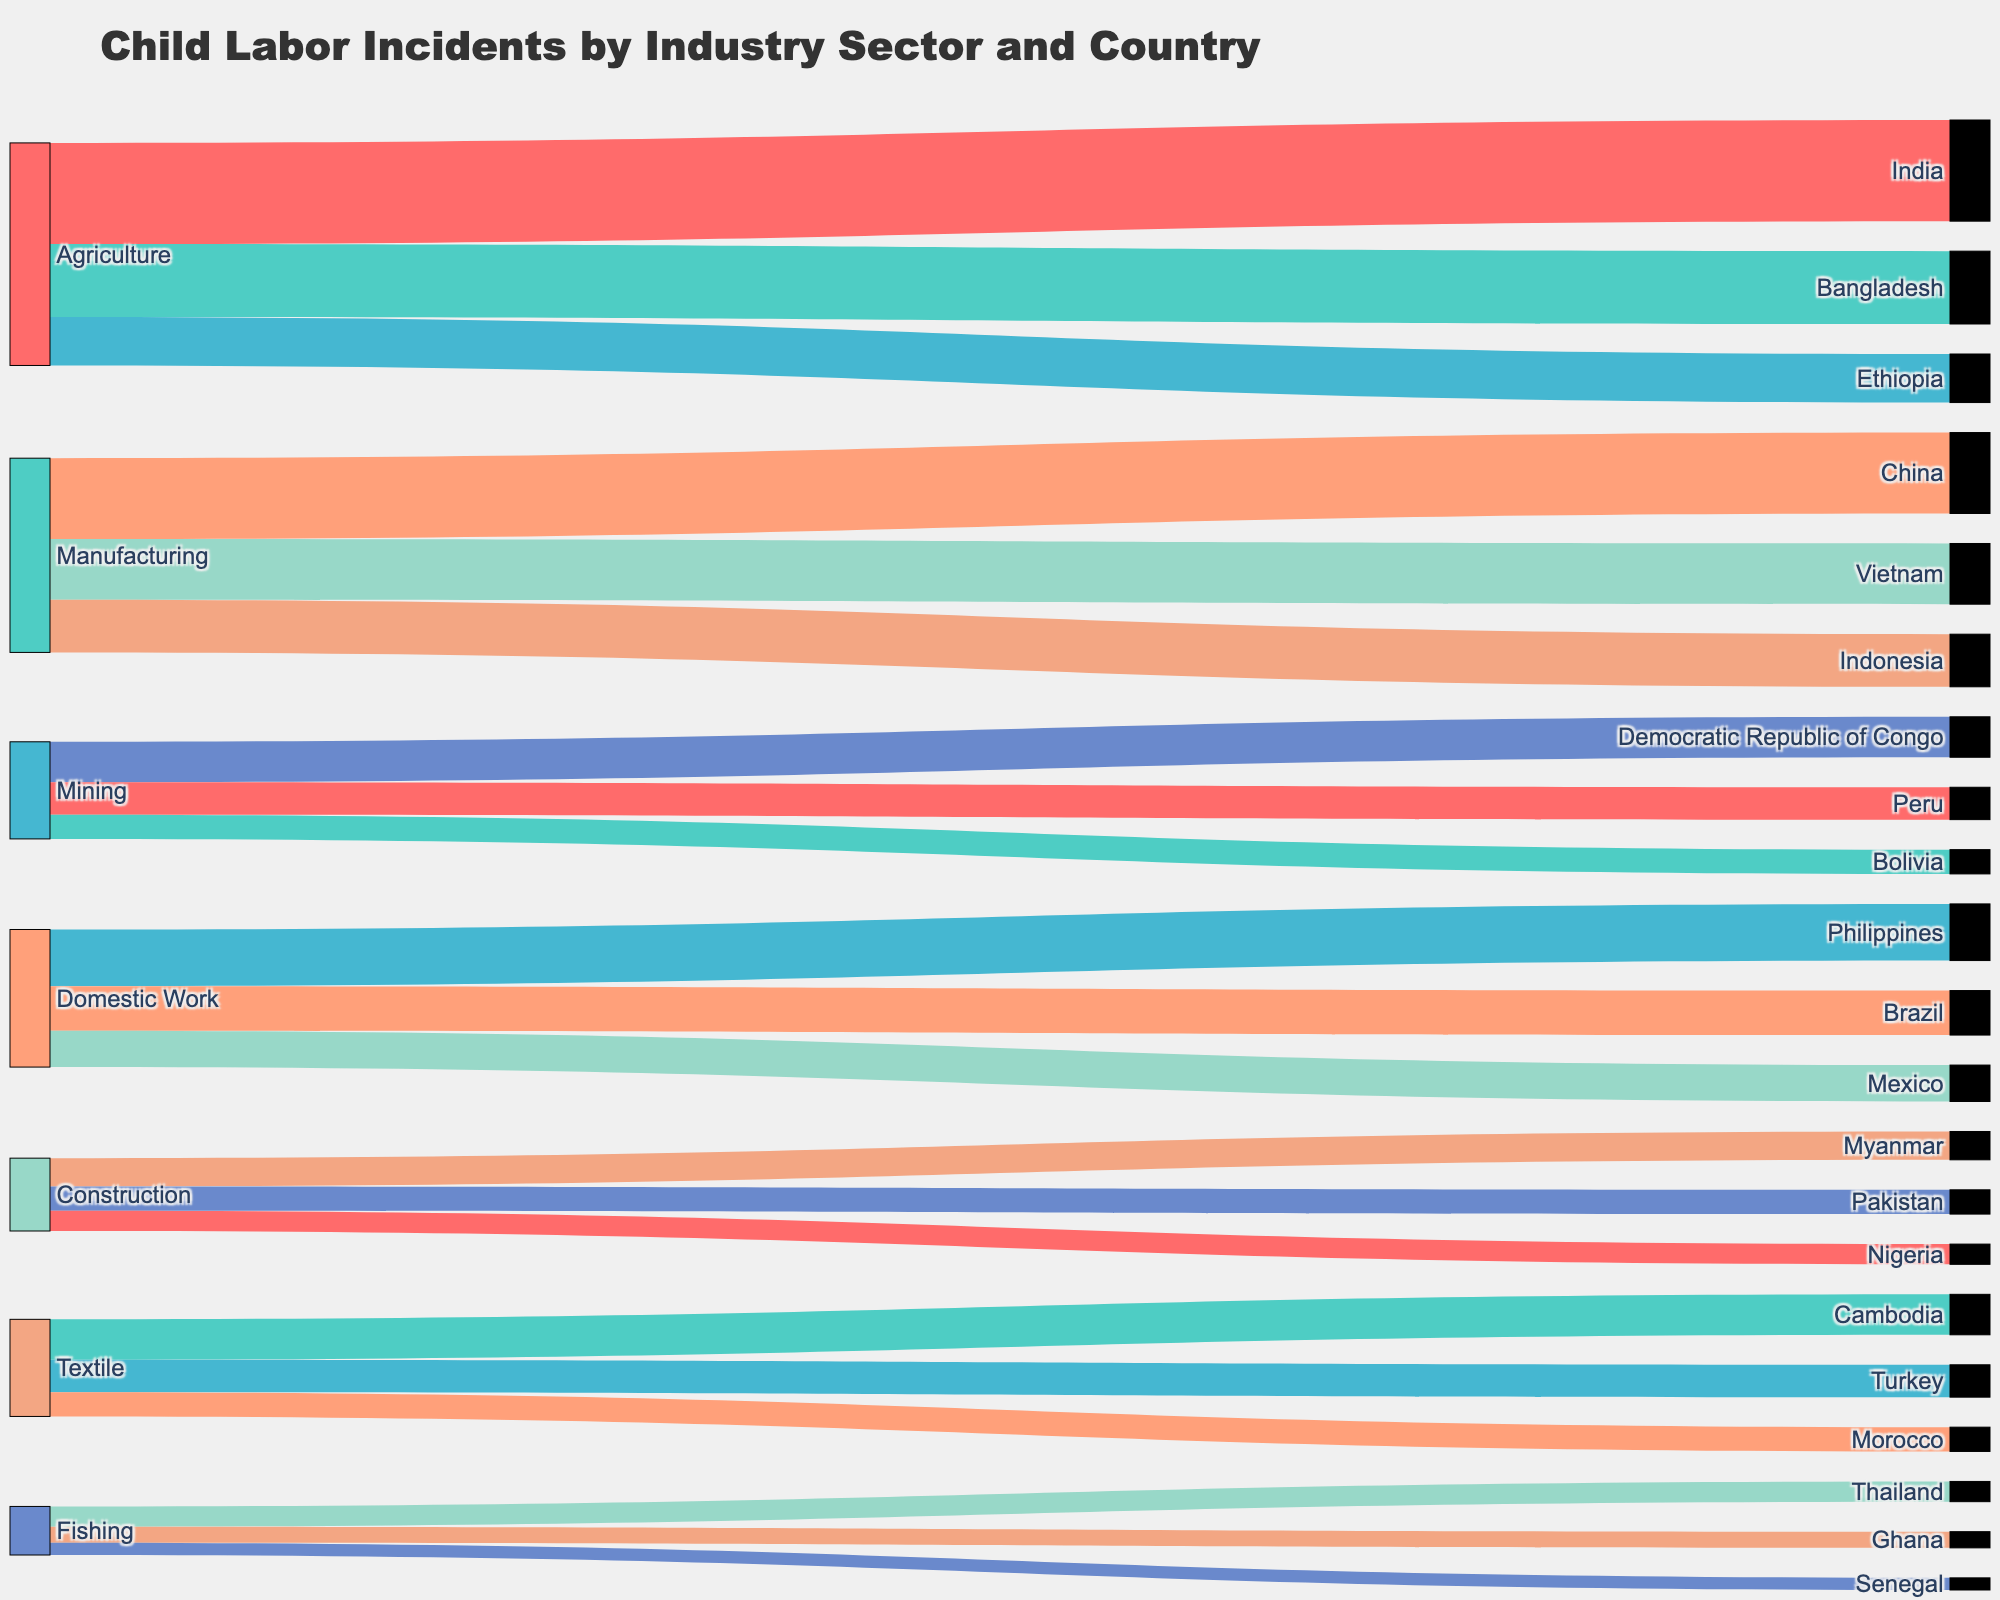What's the title of the figure? The title is prominently displayed at the top of the Sankey Diagram.
Answer: Child Labor Incidents by Industry Sector and Country Which country has the highest number of child labor incidents in the 'Agriculture' sector? Follow the 'Agriculture' flow to find the largest value connected to a country.
Answer: India How many total child labor incidents are reported in the 'Manufacturing' sector? Sum the values for all countries connected to 'Manufacturing'.
Answer: 4800 Which industry sector is associated with the fewest child labor incidents for Thailand? Look at the connections between 'Fishing' and its target to see the value.
Answer: Fishing Compare the number of child labor incidents in 'Domestic Work' in Brazil and Mexico. Which has more incidents? Check the values connected from 'Domestic Work' to both countries and compare.
Answer: Brazil What is the average number of child labor incidents in the 'Textile' sector across the three countries? Sum the values of 'Textile' for the three countries and divide by 3.
Answer: 800 Which industry sectors are associated with child labor incidents in over three countries? Identify sectors with links to more than three countries.
Answer: Agriculture, Manufacturing, Domestic Work, Textile How many more child labor incidents are reported in 'Construction' in Myanmar compared to Nigeria? Subtract the number of incidents in Nigeria from those in Myanmar.
Answer: 200 What’s the total number of child labor incidents reported in Ethiopia? Identify the value connected from the relevant industry sector (Agriculture) to Ethiopia.
Answer: 1200 Which sector has a wider range of target countries, 'Agriculture' or 'Mining'? Compare the number of countries connected to 'Agriculture' and 'Mining'.
Answer: Agriculture 